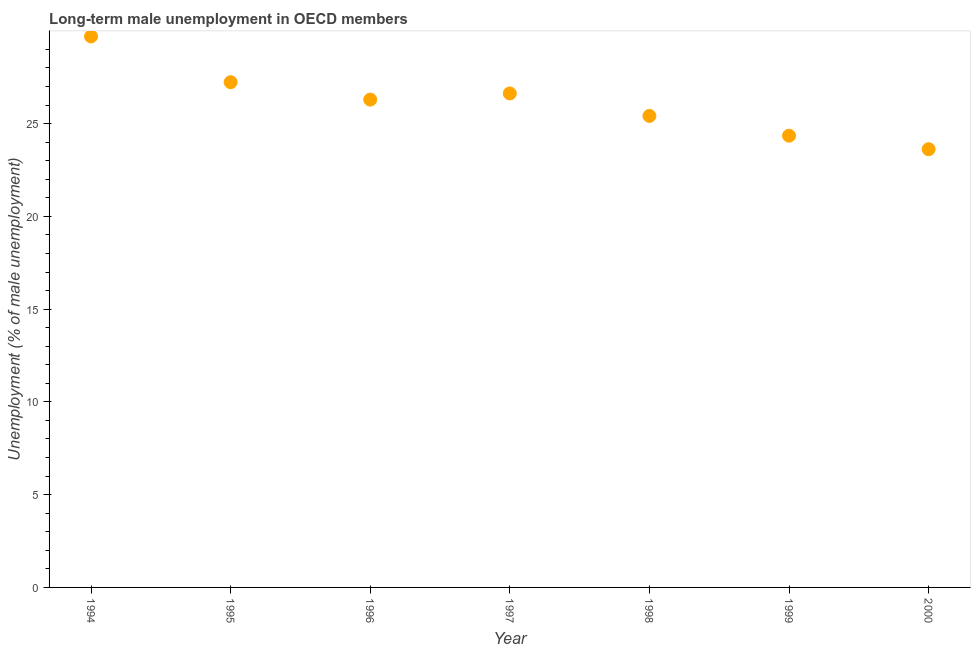What is the long-term male unemployment in 1996?
Your response must be concise. 26.29. Across all years, what is the maximum long-term male unemployment?
Offer a terse response. 29.7. Across all years, what is the minimum long-term male unemployment?
Your answer should be compact. 23.62. What is the sum of the long-term male unemployment?
Offer a very short reply. 183.22. What is the difference between the long-term male unemployment in 1996 and 2000?
Offer a terse response. 2.67. What is the average long-term male unemployment per year?
Your answer should be compact. 26.17. What is the median long-term male unemployment?
Keep it short and to the point. 26.29. In how many years, is the long-term male unemployment greater than 15 %?
Ensure brevity in your answer.  7. What is the ratio of the long-term male unemployment in 1994 to that in 1996?
Make the answer very short. 1.13. Is the long-term male unemployment in 1996 less than that in 1999?
Your response must be concise. No. Is the difference between the long-term male unemployment in 1997 and 1998 greater than the difference between any two years?
Keep it short and to the point. No. What is the difference between the highest and the second highest long-term male unemployment?
Your response must be concise. 2.46. Is the sum of the long-term male unemployment in 1994 and 2000 greater than the maximum long-term male unemployment across all years?
Your answer should be very brief. Yes. What is the difference between the highest and the lowest long-term male unemployment?
Offer a very short reply. 6.08. How many years are there in the graph?
Ensure brevity in your answer.  7. Does the graph contain any zero values?
Give a very brief answer. No. Does the graph contain grids?
Your answer should be very brief. No. What is the title of the graph?
Your response must be concise. Long-term male unemployment in OECD members. What is the label or title of the X-axis?
Provide a succinct answer. Year. What is the label or title of the Y-axis?
Offer a very short reply. Unemployment (% of male unemployment). What is the Unemployment (% of male unemployment) in 1994?
Provide a short and direct response. 29.7. What is the Unemployment (% of male unemployment) in 1995?
Keep it short and to the point. 27.23. What is the Unemployment (% of male unemployment) in 1996?
Provide a succinct answer. 26.29. What is the Unemployment (% of male unemployment) in 1997?
Your answer should be compact. 26.62. What is the Unemployment (% of male unemployment) in 1998?
Give a very brief answer. 25.41. What is the Unemployment (% of male unemployment) in 1999?
Ensure brevity in your answer.  24.35. What is the Unemployment (% of male unemployment) in 2000?
Offer a very short reply. 23.62. What is the difference between the Unemployment (% of male unemployment) in 1994 and 1995?
Your response must be concise. 2.46. What is the difference between the Unemployment (% of male unemployment) in 1994 and 1996?
Give a very brief answer. 3.4. What is the difference between the Unemployment (% of male unemployment) in 1994 and 1997?
Provide a succinct answer. 3.07. What is the difference between the Unemployment (% of male unemployment) in 1994 and 1998?
Your answer should be very brief. 4.28. What is the difference between the Unemployment (% of male unemployment) in 1994 and 1999?
Your answer should be compact. 5.35. What is the difference between the Unemployment (% of male unemployment) in 1994 and 2000?
Provide a succinct answer. 6.08. What is the difference between the Unemployment (% of male unemployment) in 1995 and 1996?
Give a very brief answer. 0.94. What is the difference between the Unemployment (% of male unemployment) in 1995 and 1997?
Offer a terse response. 0.61. What is the difference between the Unemployment (% of male unemployment) in 1995 and 1998?
Provide a succinct answer. 1.82. What is the difference between the Unemployment (% of male unemployment) in 1995 and 1999?
Offer a terse response. 2.88. What is the difference between the Unemployment (% of male unemployment) in 1995 and 2000?
Your response must be concise. 3.61. What is the difference between the Unemployment (% of male unemployment) in 1996 and 1997?
Your answer should be very brief. -0.33. What is the difference between the Unemployment (% of male unemployment) in 1996 and 1998?
Offer a very short reply. 0.88. What is the difference between the Unemployment (% of male unemployment) in 1996 and 1999?
Provide a short and direct response. 1.94. What is the difference between the Unemployment (% of male unemployment) in 1996 and 2000?
Your answer should be very brief. 2.67. What is the difference between the Unemployment (% of male unemployment) in 1997 and 1998?
Keep it short and to the point. 1.21. What is the difference between the Unemployment (% of male unemployment) in 1997 and 1999?
Offer a terse response. 2.28. What is the difference between the Unemployment (% of male unemployment) in 1997 and 2000?
Provide a succinct answer. 3.01. What is the difference between the Unemployment (% of male unemployment) in 1998 and 1999?
Keep it short and to the point. 1.07. What is the difference between the Unemployment (% of male unemployment) in 1998 and 2000?
Make the answer very short. 1.79. What is the difference between the Unemployment (% of male unemployment) in 1999 and 2000?
Offer a very short reply. 0.73. What is the ratio of the Unemployment (% of male unemployment) in 1994 to that in 1995?
Provide a short and direct response. 1.09. What is the ratio of the Unemployment (% of male unemployment) in 1994 to that in 1996?
Your answer should be very brief. 1.13. What is the ratio of the Unemployment (% of male unemployment) in 1994 to that in 1997?
Offer a terse response. 1.11. What is the ratio of the Unemployment (% of male unemployment) in 1994 to that in 1998?
Your response must be concise. 1.17. What is the ratio of the Unemployment (% of male unemployment) in 1994 to that in 1999?
Provide a succinct answer. 1.22. What is the ratio of the Unemployment (% of male unemployment) in 1994 to that in 2000?
Your answer should be very brief. 1.26. What is the ratio of the Unemployment (% of male unemployment) in 1995 to that in 1996?
Provide a succinct answer. 1.04. What is the ratio of the Unemployment (% of male unemployment) in 1995 to that in 1998?
Keep it short and to the point. 1.07. What is the ratio of the Unemployment (% of male unemployment) in 1995 to that in 1999?
Ensure brevity in your answer.  1.12. What is the ratio of the Unemployment (% of male unemployment) in 1995 to that in 2000?
Keep it short and to the point. 1.15. What is the ratio of the Unemployment (% of male unemployment) in 1996 to that in 1997?
Your answer should be compact. 0.99. What is the ratio of the Unemployment (% of male unemployment) in 1996 to that in 1998?
Keep it short and to the point. 1.03. What is the ratio of the Unemployment (% of male unemployment) in 1996 to that in 1999?
Ensure brevity in your answer.  1.08. What is the ratio of the Unemployment (% of male unemployment) in 1996 to that in 2000?
Make the answer very short. 1.11. What is the ratio of the Unemployment (% of male unemployment) in 1997 to that in 1998?
Your answer should be very brief. 1.05. What is the ratio of the Unemployment (% of male unemployment) in 1997 to that in 1999?
Offer a very short reply. 1.09. What is the ratio of the Unemployment (% of male unemployment) in 1997 to that in 2000?
Your response must be concise. 1.13. What is the ratio of the Unemployment (% of male unemployment) in 1998 to that in 1999?
Offer a terse response. 1.04. What is the ratio of the Unemployment (% of male unemployment) in 1998 to that in 2000?
Keep it short and to the point. 1.08. What is the ratio of the Unemployment (% of male unemployment) in 1999 to that in 2000?
Make the answer very short. 1.03. 